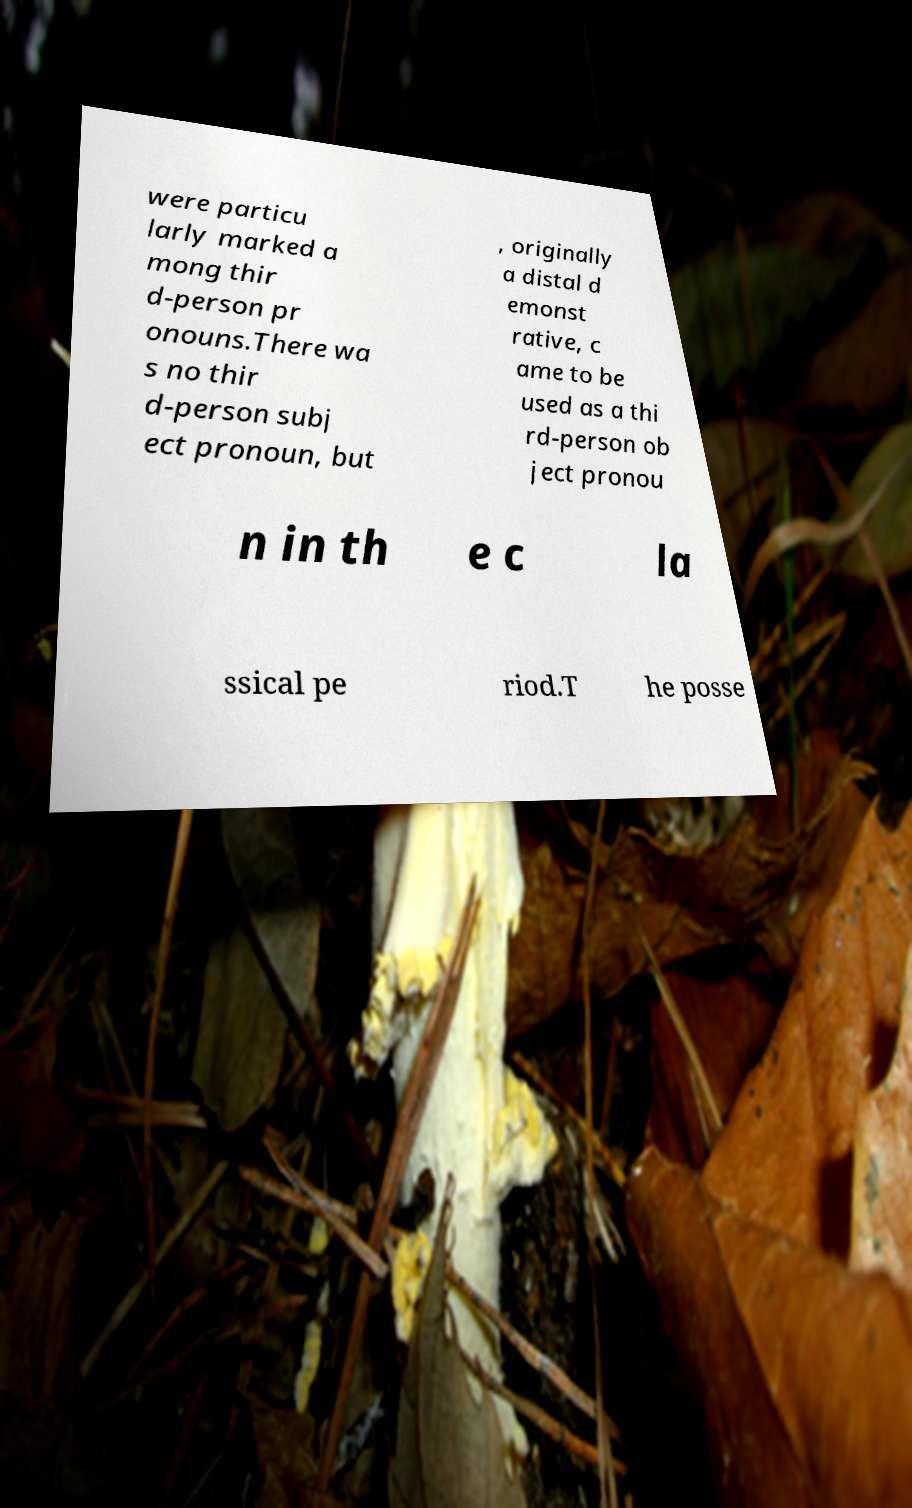Please read and relay the text visible in this image. What does it say? were particu larly marked a mong thir d-person pr onouns.There wa s no thir d-person subj ect pronoun, but , originally a distal d emonst rative, c ame to be used as a thi rd-person ob ject pronou n in th e c la ssical pe riod.T he posse 